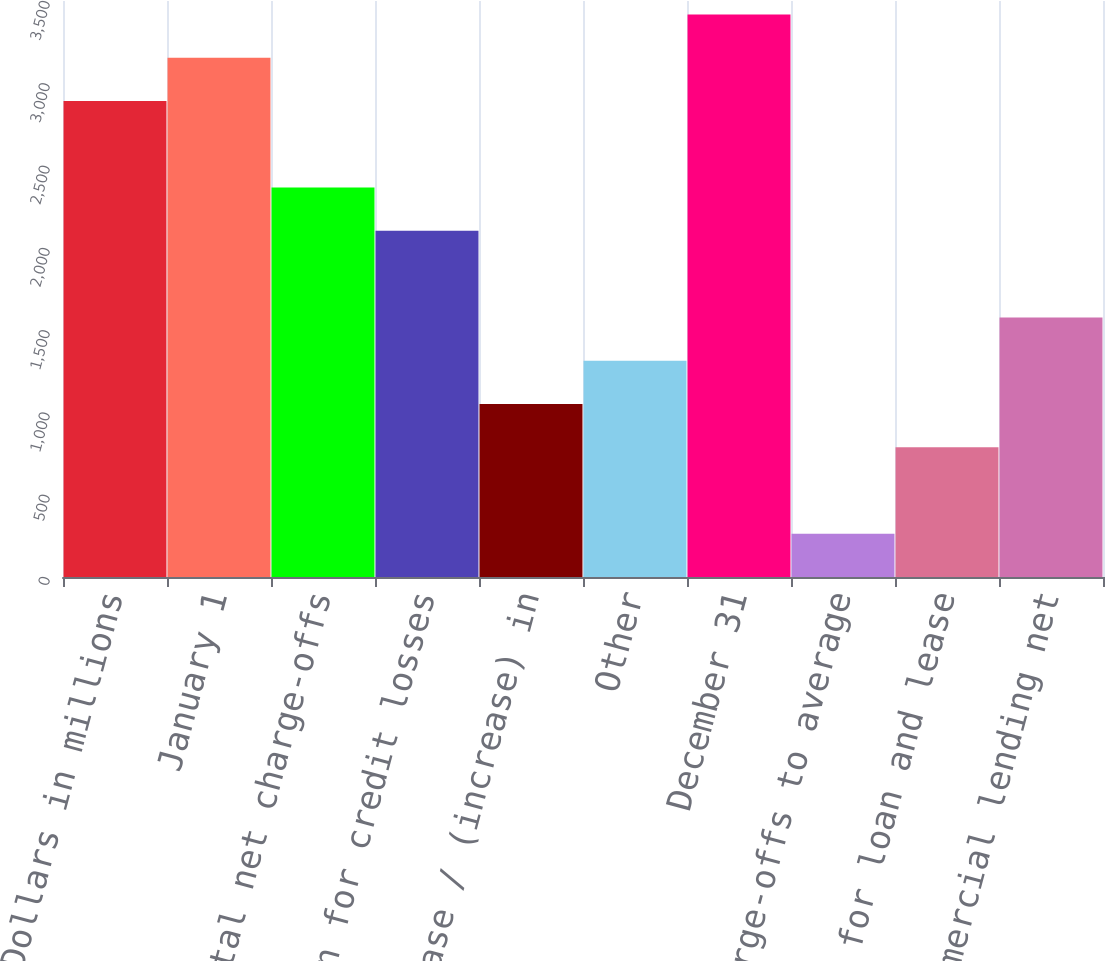Convert chart to OTSL. <chart><loc_0><loc_0><loc_500><loc_500><bar_chart><fcel>Dollars in millions<fcel>January 1<fcel>Total net charge-offs<fcel>Provision for credit losses<fcel>Net decrease / (increase) in<fcel>Other<fcel>December 31<fcel>Net charge-offs to average<fcel>Allowance for loan and lease<fcel>Commercial lending net<nl><fcel>2891.92<fcel>3154.82<fcel>2366.12<fcel>2103.22<fcel>1051.62<fcel>1314.52<fcel>3417.72<fcel>262.92<fcel>788.72<fcel>1577.42<nl></chart> 